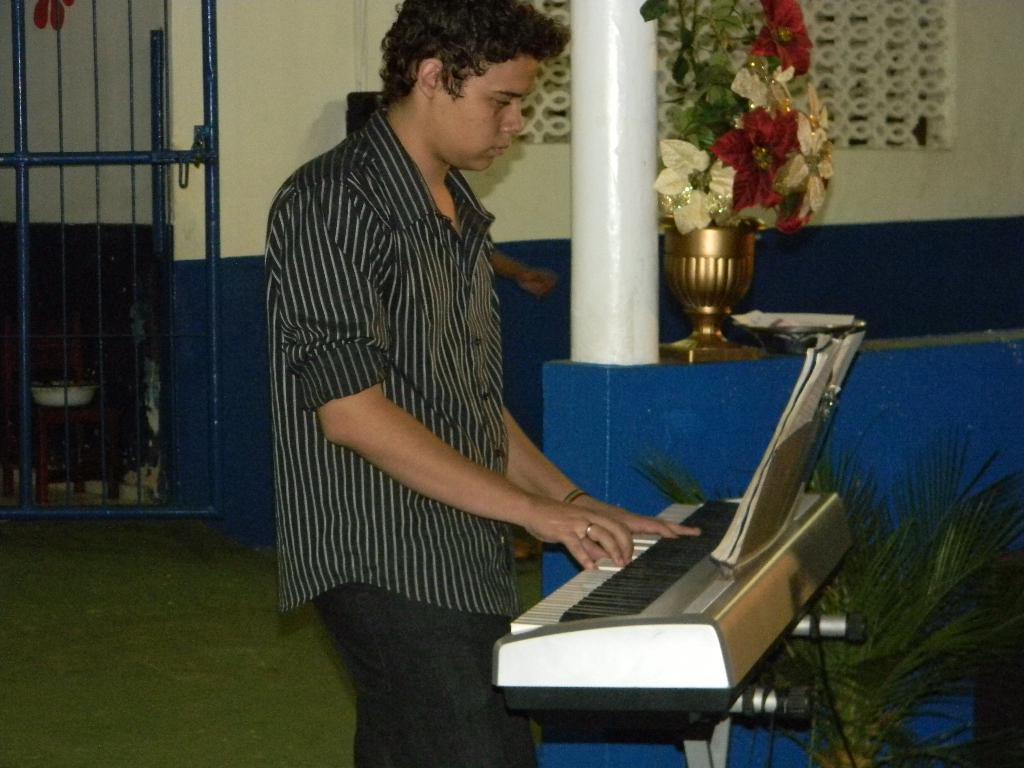What is the man in the image doing? The man is standing and playing piano. What objects can be seen in the image besides the man and the piano? There is a flower vase, a pillar, a houseplant, and a blue grilled gate in the background of the image. What type of train can be seen passing by in the image? There is no train present in the image. Can you describe the nest of the bird that is sitting on the houseplant? There is no bird or nest visible on the houseplant in the image. 